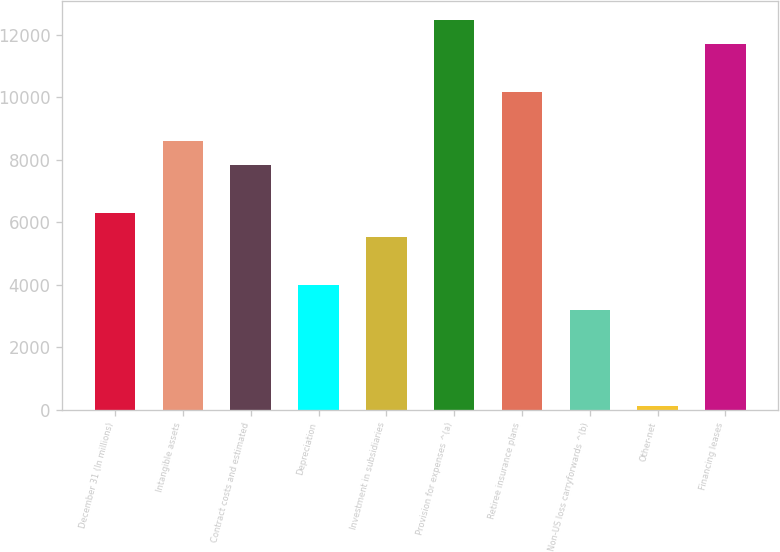Convert chart to OTSL. <chart><loc_0><loc_0><loc_500><loc_500><bar_chart><fcel>December 31 (In millions)<fcel>Intangible assets<fcel>Contract costs and estimated<fcel>Depreciation<fcel>Investment in subsidiaries<fcel>Provision for expenses ^(a)<fcel>Retiree insurance plans<fcel>Non-US loss carryforwards ^(b)<fcel>Other-net<fcel>Financing leases<nl><fcel>6297.4<fcel>8615.8<fcel>7843<fcel>3979<fcel>5524.6<fcel>12479.8<fcel>10161.4<fcel>3206.2<fcel>115<fcel>11707<nl></chart> 